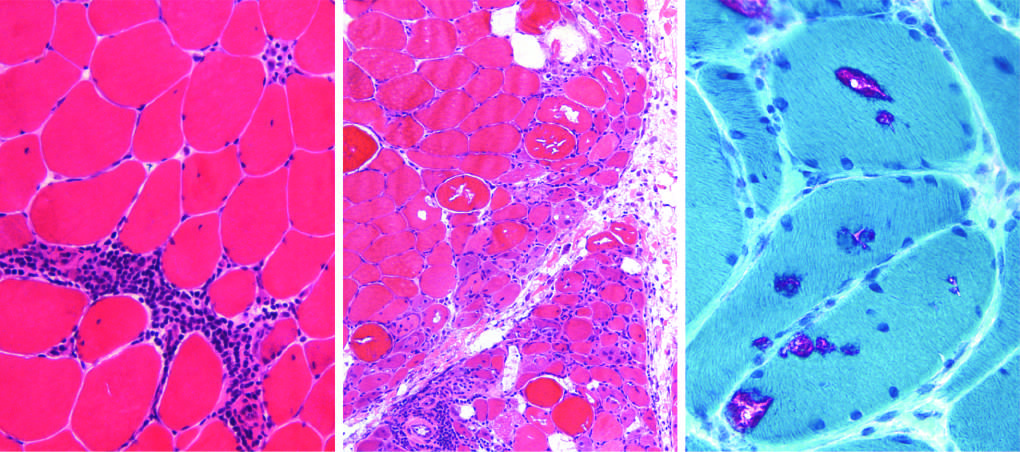s gomori trichrome stain modified?
Answer the question using a single word or phrase. Yes 